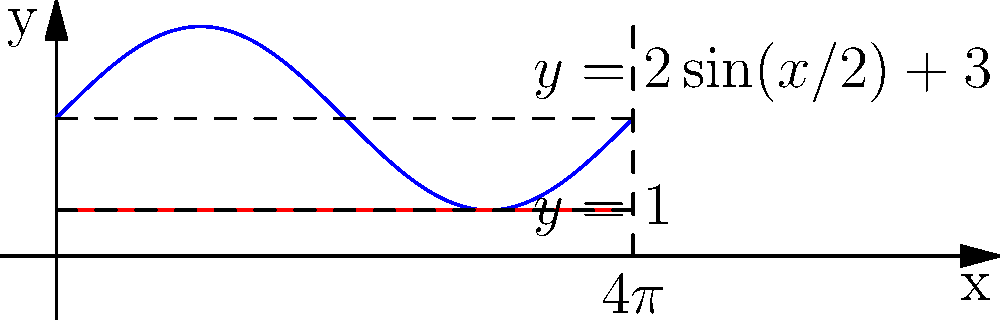In a whimsical realm, a peculiar creature resides in a dwelling shaped by revolving the curve $y = 2\sin(x/2) + 3$ around the x-axis from $x = 0$ to $x = 4\pi$. The creature's abode has a magical lower bound at $y = 1$. Calculate the volume of this fantastical living space. To find the volume of this unusual dwelling, we'll use the washer method:

1) The outer radius is given by $r_{outer} = 2\sin(x/2) + 3$
2) The inner radius is constant: $r_{inner} = 1$

3) The volume formula using the washer method is:
   $$V = \pi \int_a^b [(R(x))^2 - (r(x))^2] dx$$

4) Substituting our values:
   $$V = \pi \int_0^{4\pi} [(2\sin(x/2) + 3)^2 - 1^2] dx$$

5) Expand the squared term:
   $$V = \pi \int_0^{4\pi} [4\sin^2(x/2) + 12\sin(x/2) + 9 - 1] dx$$
   $$V = \pi \int_0^{4\pi} [4\sin^2(x/2) + 12\sin(x/2) + 8] dx$$

6) Integrate each term:
   - $\int \sin^2(x/2) dx = \frac{1}{2}[x - \sin(x)]$
   - $\int \sin(x/2) dx = -2\cos(x/2)$
   - $\int 8 dx = 8x$

7) Apply the limits:
   $$V = \pi [2(4\pi - \sin(4\pi)) - 24(\cos(2\pi) - \cos(0)) + 32\pi]$$

8) Simplify:
   $$V = \pi [8\pi + 24 + 32\pi]$$
   $$V = 40\pi^2 + 24\pi$$
Answer: $40\pi^2 + 24\pi$ cubic units 